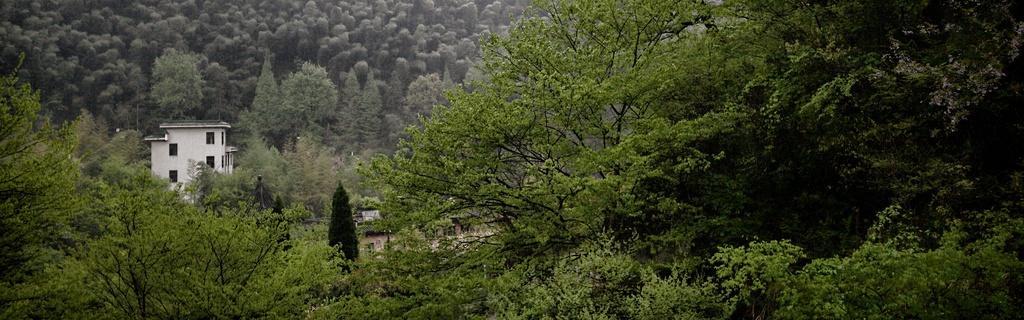Could you give a brief overview of what you see in this image? In the foreground of the image there are trees. To the left side of the image there is a building. In the background of the image there are trees. 